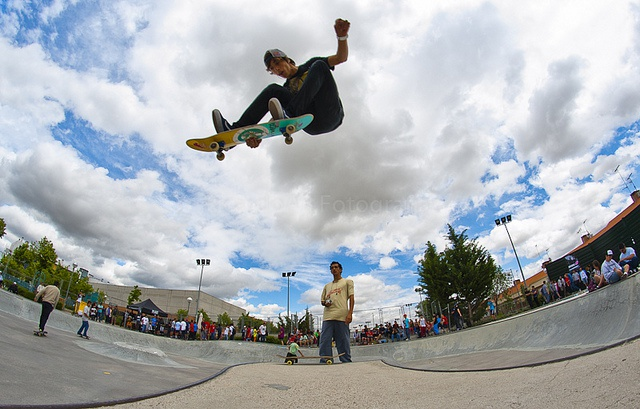Describe the objects in this image and their specific colors. I can see people in lightblue, black, darkgray, gray, and lightgray tones, people in lightblue, black, maroon, gray, and lightgray tones, people in lightblue, black, tan, gray, and olive tones, skateboard in lightblue, olive, gray, black, and teal tones, and people in lightblue, black, gray, and darkgray tones in this image. 